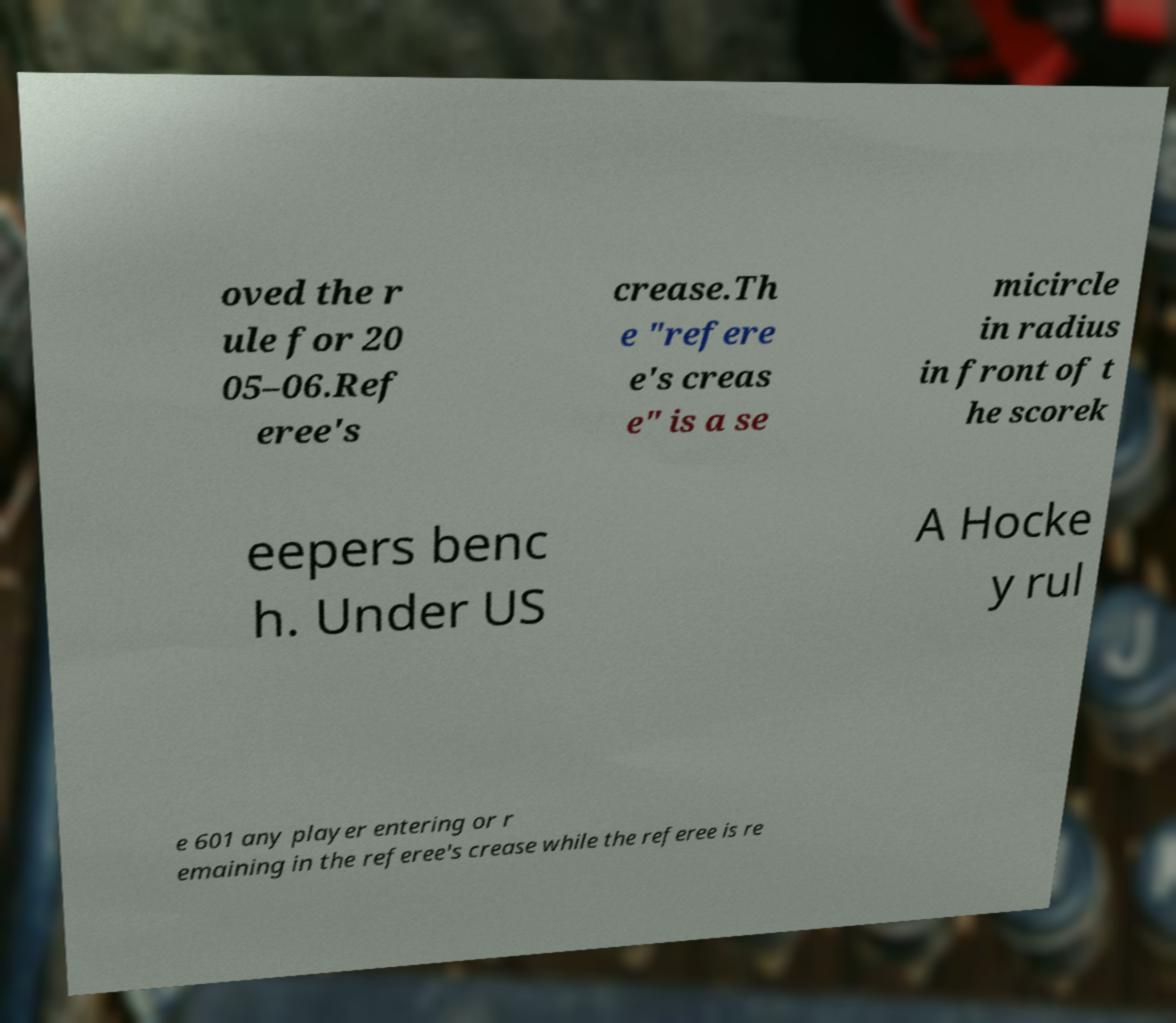I need the written content from this picture converted into text. Can you do that? oved the r ule for 20 05–06.Ref eree's crease.Th e "refere e's creas e" is a se micircle in radius in front of t he scorek eepers benc h. Under US A Hocke y rul e 601 any player entering or r emaining in the referee's crease while the referee is re 